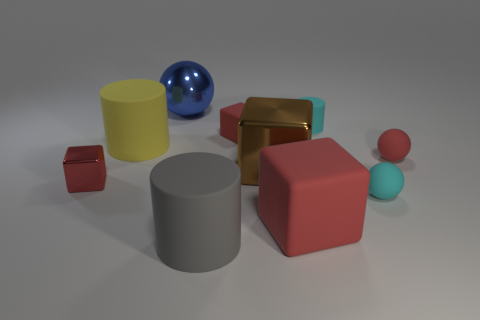The ball that is to the left of the red matte block that is in front of the small cube that is left of the blue sphere is made of what material?
Offer a very short reply. Metal. How many tiny things are either cyan objects or red matte blocks?
Provide a short and direct response. 3. What number of other objects are the same size as the gray thing?
Your answer should be very brief. 4. There is a metal object that is on the right side of the large blue shiny sphere; does it have the same shape as the large gray thing?
Offer a terse response. No. There is another large thing that is the same shape as the gray object; what color is it?
Provide a succinct answer. Yellow. Are there any other things that have the same shape as the big blue object?
Offer a very short reply. Yes. Are there the same number of cyan objects to the left of the small red shiny object and small red cubes?
Offer a very short reply. No. How many matte objects are on the left side of the brown thing and behind the brown block?
Make the answer very short. 2. There is a cyan matte object that is the same shape as the large blue shiny object; what is its size?
Give a very brief answer. Small. How many cyan cylinders are made of the same material as the large yellow thing?
Your response must be concise. 1. 